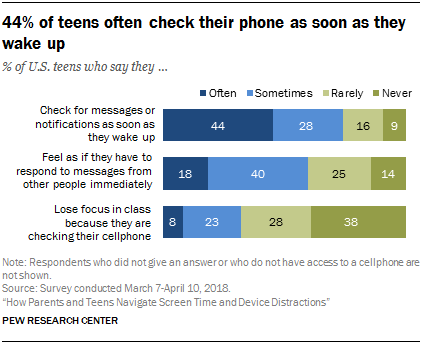Outline some significant characteristics in this image. According to the survey, the percentage of teens who choose to rarely engage in the first issue is 16%. Approximately 25% of the people surveyed chose "rarely or never" as their primary category for engaging in their hobby. 